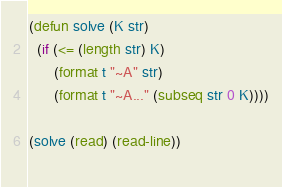Convert code to text. <code><loc_0><loc_0><loc_500><loc_500><_Lisp_>(defun solve (K str)
  (if (<= (length str) K)
      (format t "~A" str)
      (format t "~A..." (subseq str 0 K))))

(solve (read) (read-line))
  </code> 